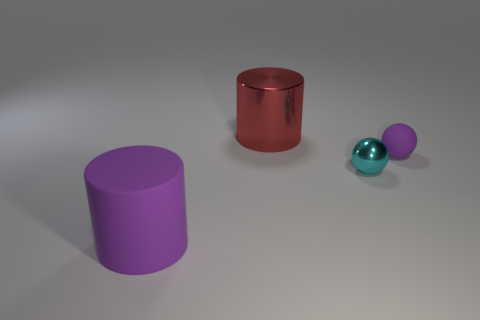Does the big matte cylinder have the same color as the small sphere that is in front of the small purple rubber thing?
Keep it short and to the point. No. The small matte sphere is what color?
Make the answer very short. Purple. There is a purple matte object to the right of the matte object on the left side of the purple object right of the metal cylinder; what is its shape?
Give a very brief answer. Sphere. How many other things are there of the same color as the tiny rubber object?
Give a very brief answer. 1. Is the number of purple rubber balls that are right of the tiny metal thing greater than the number of cylinders behind the big red cylinder?
Your response must be concise. Yes. Are there any red cylinders to the left of the large purple matte thing?
Keep it short and to the point. No. What material is the object that is in front of the tiny purple thing and to the right of the big purple cylinder?
Your answer should be compact. Metal. The matte thing that is the same shape as the red shiny object is what color?
Offer a terse response. Purple. There is a rubber thing that is in front of the tiny purple matte ball; are there any balls that are in front of it?
Your answer should be very brief. No. The matte sphere has what size?
Offer a very short reply. Small. 